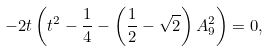Convert formula to latex. <formula><loc_0><loc_0><loc_500><loc_500>- 2 t \left ( t ^ { 2 } - \frac { 1 } { 4 } - \left ( \frac { 1 } { 2 } - \sqrt { 2 } \right ) A _ { 9 } ^ { 2 } \right ) = 0 ,</formula> 